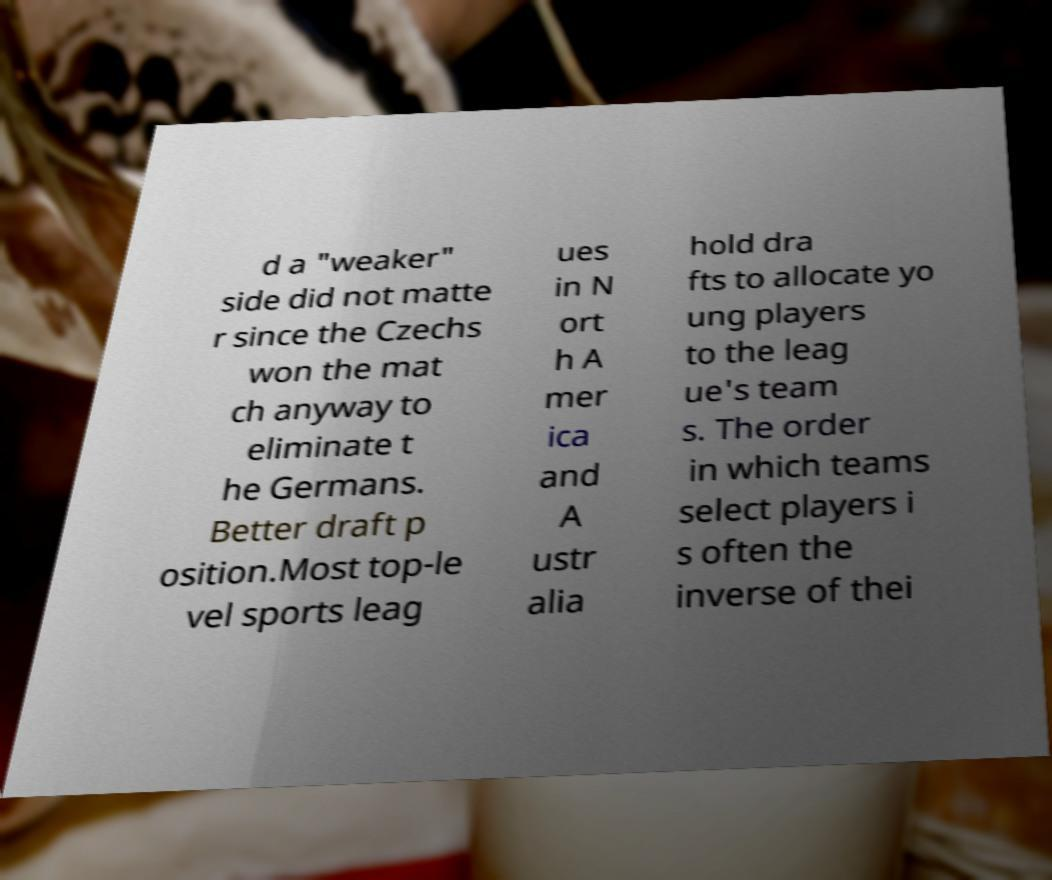Could you extract and type out the text from this image? d a "weaker" side did not matte r since the Czechs won the mat ch anyway to eliminate t he Germans. Better draft p osition.Most top-le vel sports leag ues in N ort h A mer ica and A ustr alia hold dra fts to allocate yo ung players to the leag ue's team s. The order in which teams select players i s often the inverse of thei 